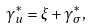<formula> <loc_0><loc_0><loc_500><loc_500>\gamma _ { u } ^ { * } = \xi + \gamma _ { \sigma } ^ { * } ,</formula> 